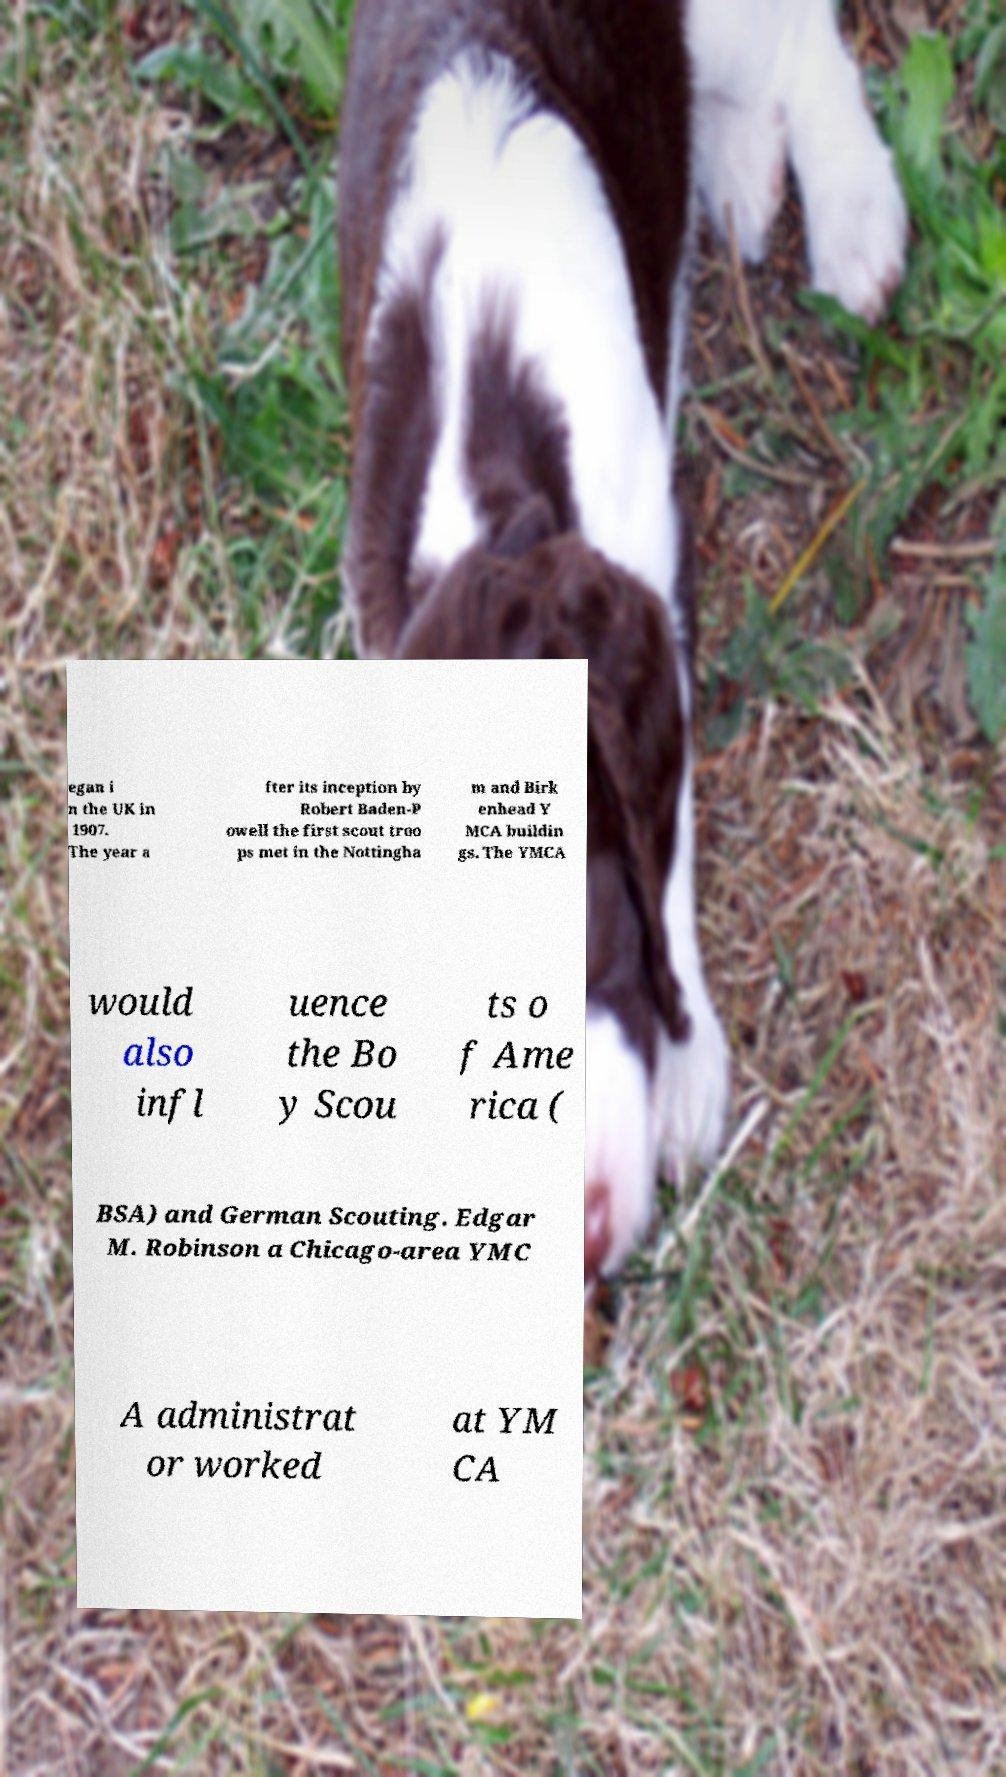There's text embedded in this image that I need extracted. Can you transcribe it verbatim? egan i n the UK in 1907. The year a fter its inception by Robert Baden-P owell the first scout troo ps met in the Nottingha m and Birk enhead Y MCA buildin gs. The YMCA would also infl uence the Bo y Scou ts o f Ame rica ( BSA) and German Scouting. Edgar M. Robinson a Chicago-area YMC A administrat or worked at YM CA 